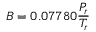<formula> <loc_0><loc_0><loc_500><loc_500>B = 0 . 0 7 7 8 0 { \frac { P _ { r } } { T _ { r } } }</formula> 